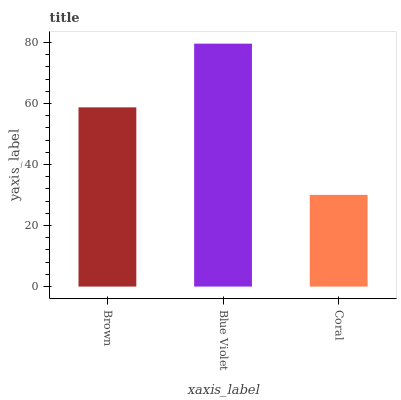Is Coral the minimum?
Answer yes or no. Yes. Is Blue Violet the maximum?
Answer yes or no. Yes. Is Blue Violet the minimum?
Answer yes or no. No. Is Coral the maximum?
Answer yes or no. No. Is Blue Violet greater than Coral?
Answer yes or no. Yes. Is Coral less than Blue Violet?
Answer yes or no. Yes. Is Coral greater than Blue Violet?
Answer yes or no. No. Is Blue Violet less than Coral?
Answer yes or no. No. Is Brown the high median?
Answer yes or no. Yes. Is Brown the low median?
Answer yes or no. Yes. Is Coral the high median?
Answer yes or no. No. Is Coral the low median?
Answer yes or no. No. 